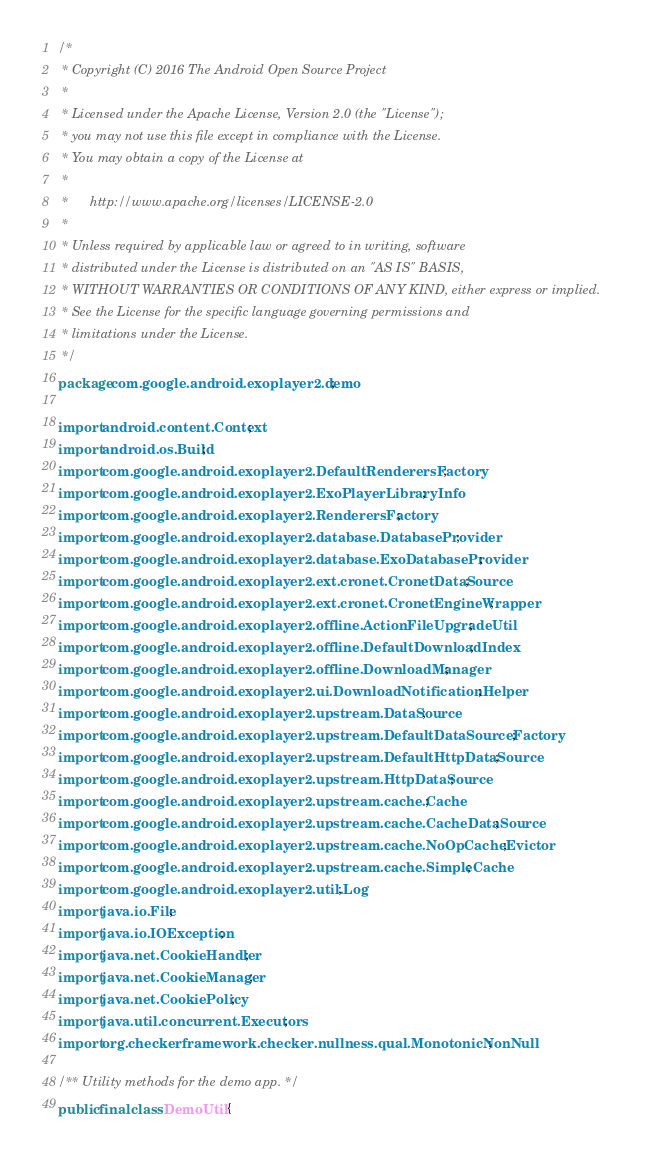<code> <loc_0><loc_0><loc_500><loc_500><_Java_>/*
 * Copyright (C) 2016 The Android Open Source Project
 *
 * Licensed under the Apache License, Version 2.0 (the "License");
 * you may not use this file except in compliance with the License.
 * You may obtain a copy of the License at
 *
 *      http://www.apache.org/licenses/LICENSE-2.0
 *
 * Unless required by applicable law or agreed to in writing, software
 * distributed under the License is distributed on an "AS IS" BASIS,
 * WITHOUT WARRANTIES OR CONDITIONS OF ANY KIND, either express or implied.
 * See the License for the specific language governing permissions and
 * limitations under the License.
 */
package com.google.android.exoplayer2.demo;

import android.content.Context;
import android.os.Build;
import com.google.android.exoplayer2.DefaultRenderersFactory;
import com.google.android.exoplayer2.ExoPlayerLibraryInfo;
import com.google.android.exoplayer2.RenderersFactory;
import com.google.android.exoplayer2.database.DatabaseProvider;
import com.google.android.exoplayer2.database.ExoDatabaseProvider;
import com.google.android.exoplayer2.ext.cronet.CronetDataSource;
import com.google.android.exoplayer2.ext.cronet.CronetEngineWrapper;
import com.google.android.exoplayer2.offline.ActionFileUpgradeUtil;
import com.google.android.exoplayer2.offline.DefaultDownloadIndex;
import com.google.android.exoplayer2.offline.DownloadManager;
import com.google.android.exoplayer2.ui.DownloadNotificationHelper;
import com.google.android.exoplayer2.upstream.DataSource;
import com.google.android.exoplayer2.upstream.DefaultDataSourceFactory;
import com.google.android.exoplayer2.upstream.DefaultHttpDataSource;
import com.google.android.exoplayer2.upstream.HttpDataSource;
import com.google.android.exoplayer2.upstream.cache.Cache;
import com.google.android.exoplayer2.upstream.cache.CacheDataSource;
import com.google.android.exoplayer2.upstream.cache.NoOpCacheEvictor;
import com.google.android.exoplayer2.upstream.cache.SimpleCache;
import com.google.android.exoplayer2.util.Log;
import java.io.File;
import java.io.IOException;
import java.net.CookieHandler;
import java.net.CookieManager;
import java.net.CookiePolicy;
import java.util.concurrent.Executors;
import org.checkerframework.checker.nullness.qual.MonotonicNonNull;

/** Utility methods for the demo app. */
public final class DemoUtil {
</code> 